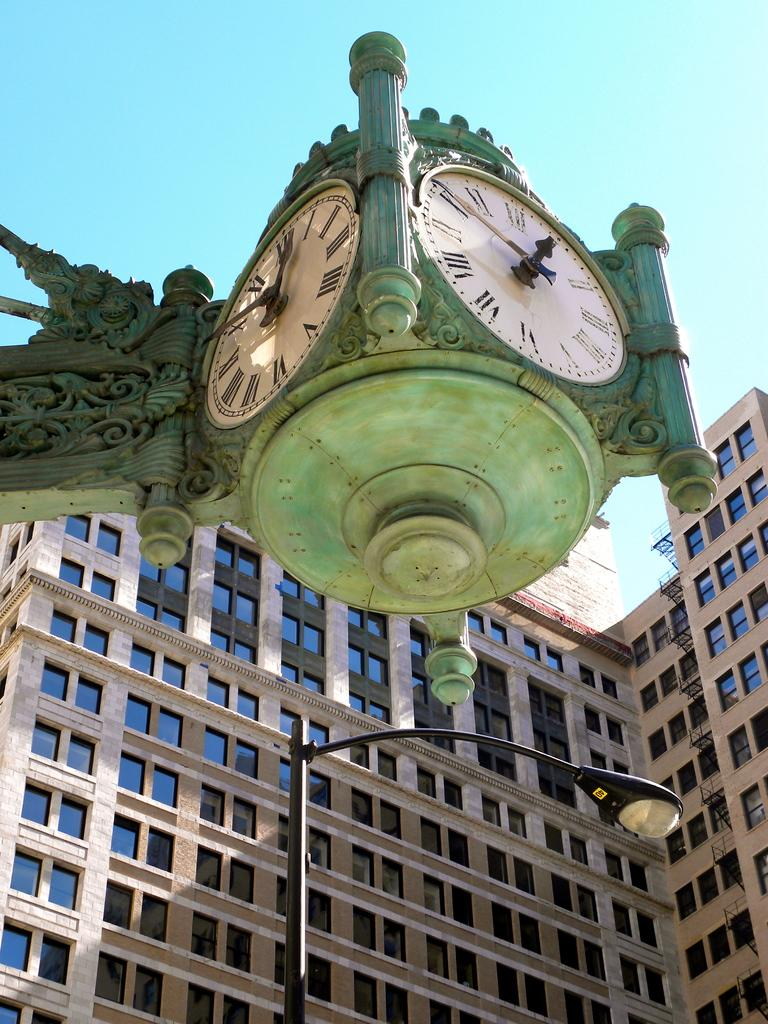<image>
Relay a brief, clear account of the picture shown. the numbers in roman numeral form are on a clock 